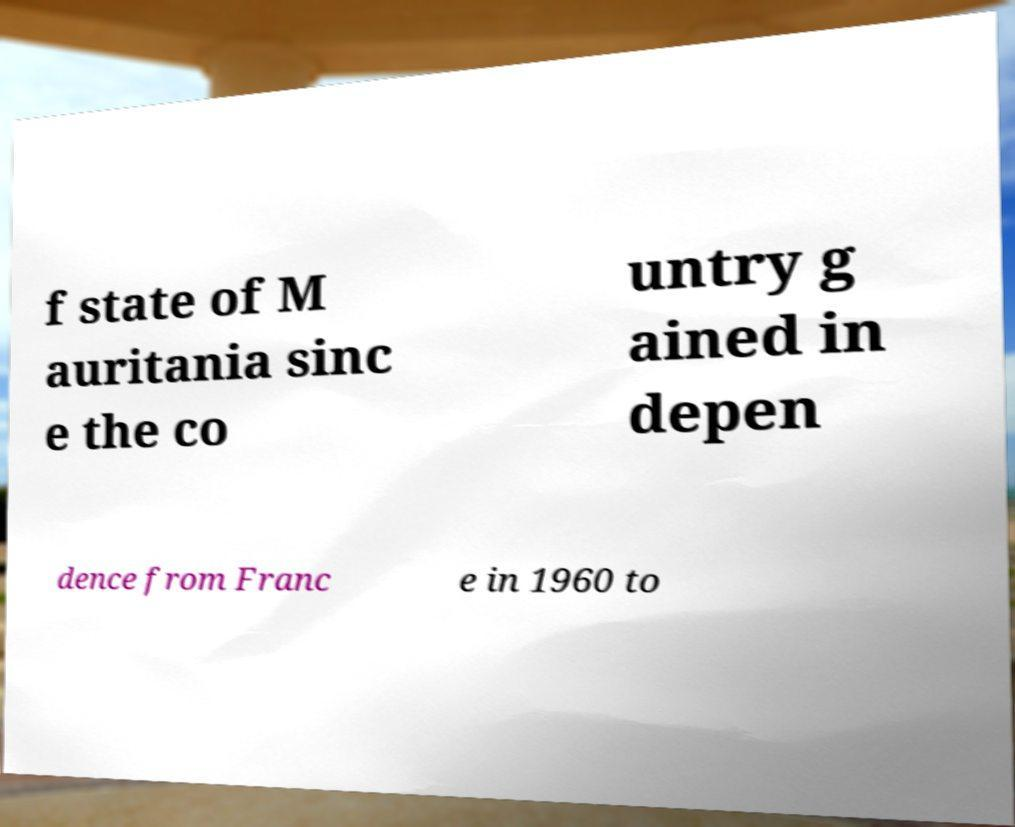Can you accurately transcribe the text from the provided image for me? f state of M auritania sinc e the co untry g ained in depen dence from Franc e in 1960 to 